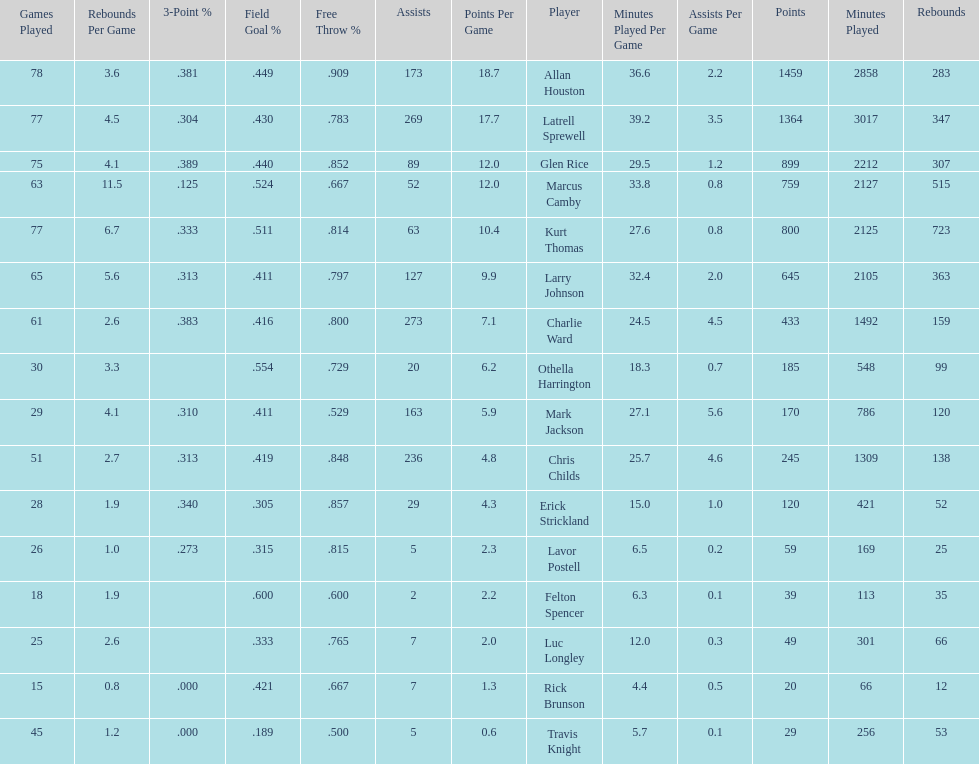How many more games did allan houston play than mark jackson? 49. 